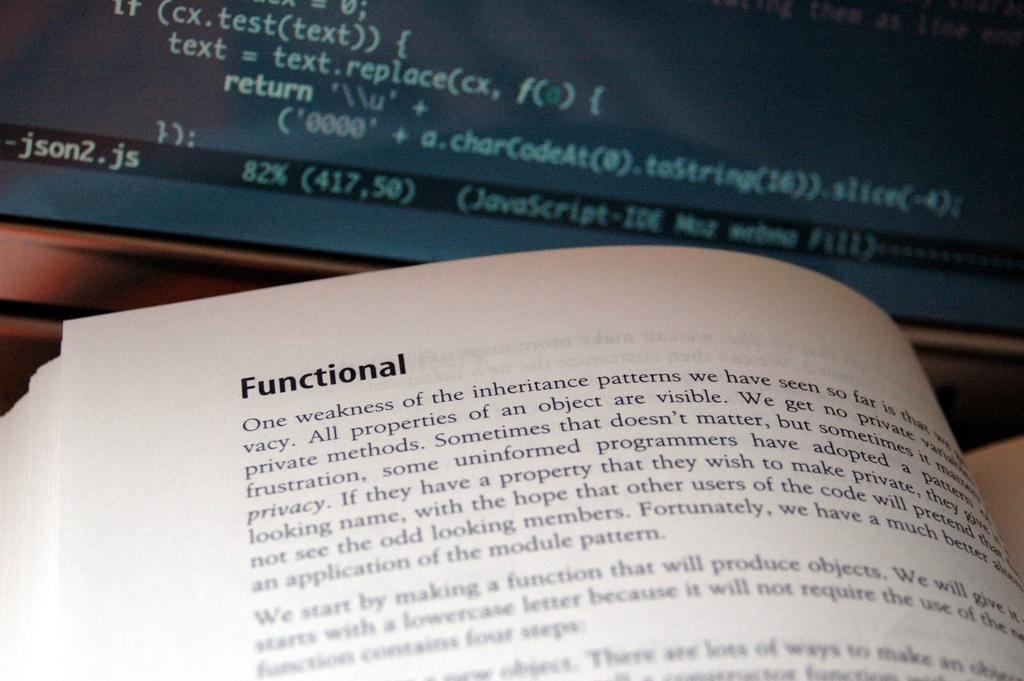This paragraph is talking about a weakness of what pattern?
Keep it short and to the point. Inheritance. What is the word at the top of the page?
Make the answer very short. Functional. 